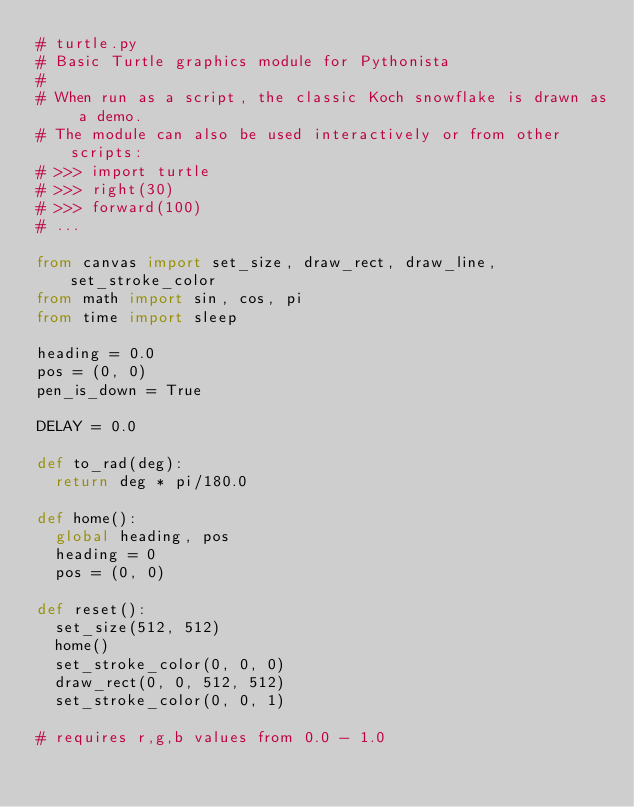<code> <loc_0><loc_0><loc_500><loc_500><_Python_># turtle.py
# Basic Turtle graphics module for Pythonista
# 
# When run as a script, the classic Koch snowflake is drawn as a demo.
# The module can also be used interactively or from other scripts:
# >>> import turtle
# >>> right(30)
# >>> forward(100)
# ...

from canvas import set_size, draw_rect, draw_line, set_stroke_color
from math import sin, cos, pi
from time import sleep

heading = 0.0
pos = (0, 0)
pen_is_down = True

DELAY = 0.0

def to_rad(deg):
	return deg * pi/180.0

def home():
	global heading, pos
	heading = 0
	pos = (0, 0)

def reset():
	set_size(512, 512)
	home()
	set_stroke_color(0, 0, 0)
	draw_rect(0, 0, 512, 512)
	set_stroke_color(0, 0, 1)
	
# requires r,g,b values from 0.0 - 1.0
</code> 